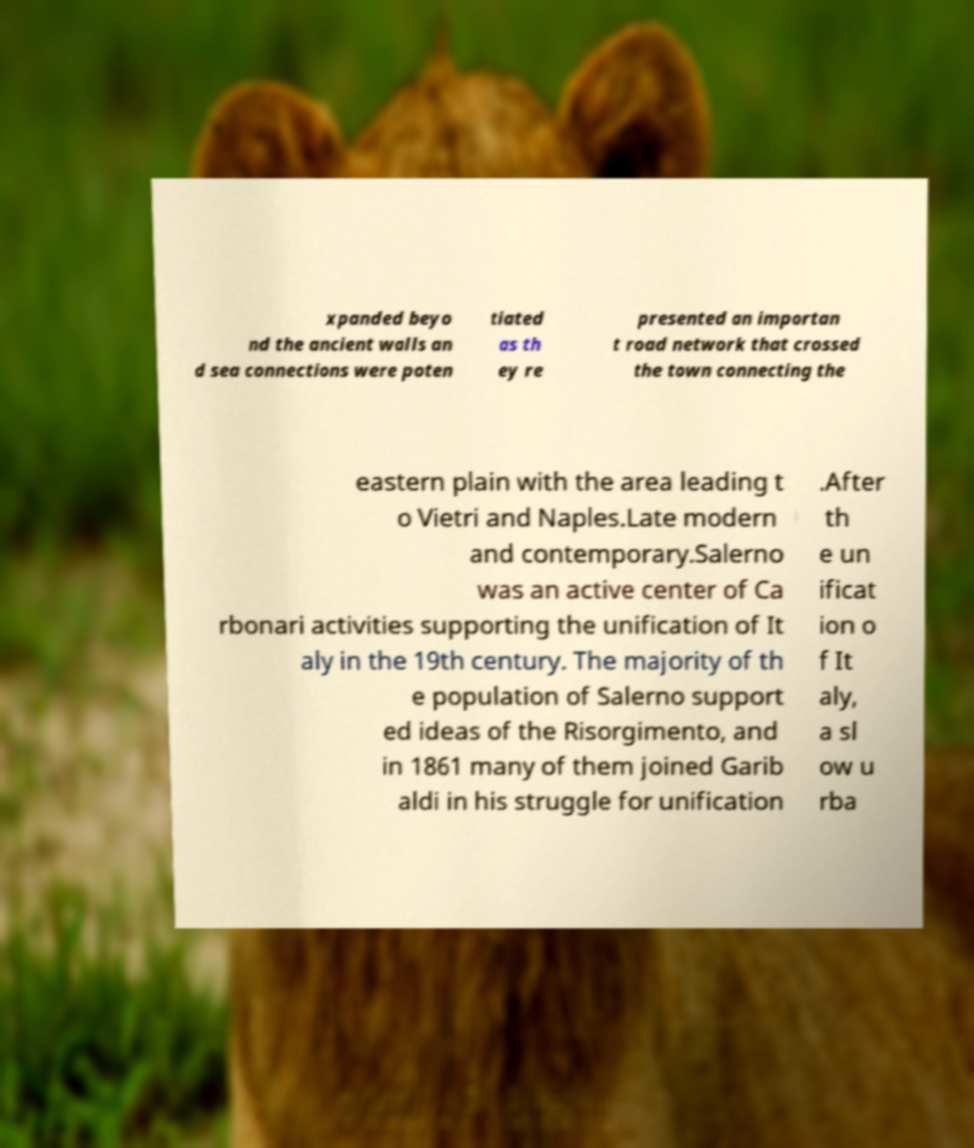Could you extract and type out the text from this image? xpanded beyo nd the ancient walls an d sea connections were poten tiated as th ey re presented an importan t road network that crossed the town connecting the eastern plain with the area leading t o Vietri and Naples.Late modern and contemporary.Salerno was an active center of Ca rbonari activities supporting the unification of It aly in the 19th century. The majority of th e population of Salerno support ed ideas of the Risorgimento, and in 1861 many of them joined Garib aldi in his struggle for unification .After th e un ificat ion o f It aly, a sl ow u rba 